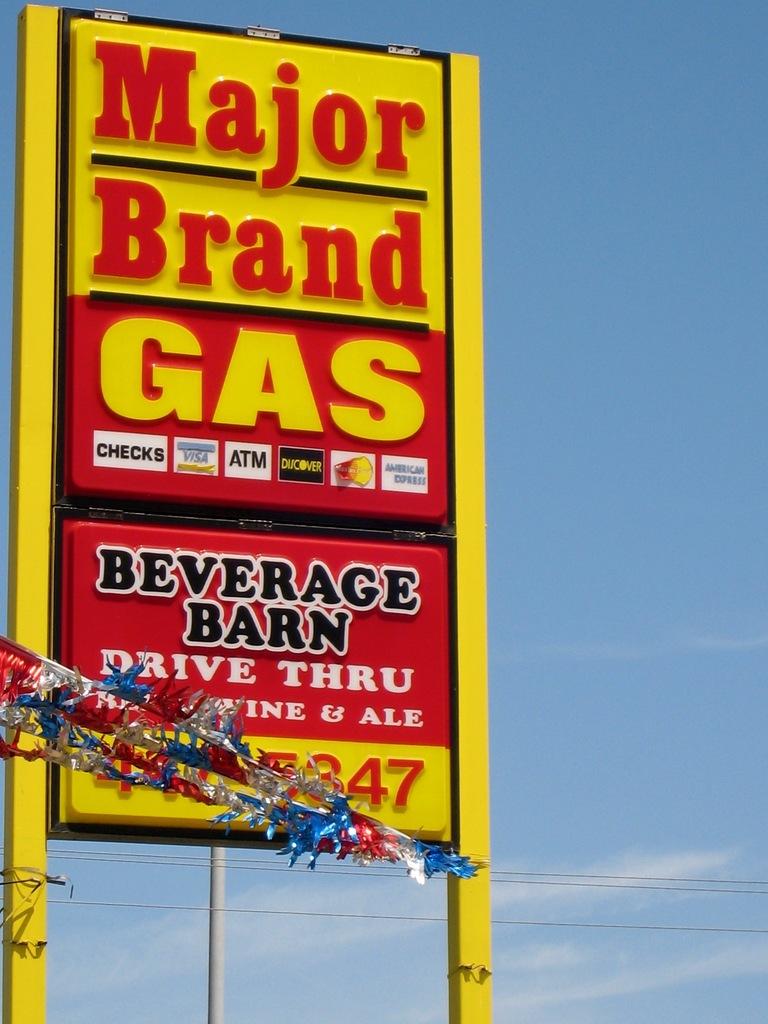Is this gas a major or minor brand?
Keep it short and to the point. Major. 